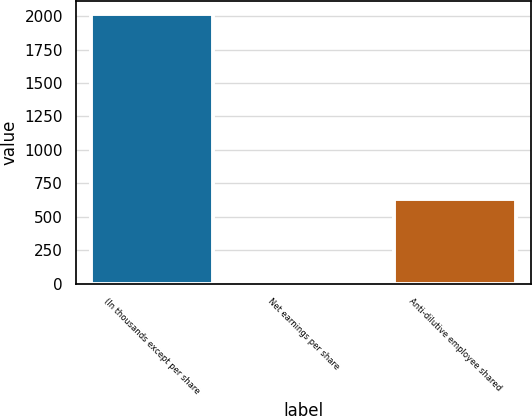Convert chart to OTSL. <chart><loc_0><loc_0><loc_500><loc_500><bar_chart><fcel>(In thousands except per share<fcel>Net earnings per share<fcel>Anti-dilutive employee shared<nl><fcel>2014<fcel>3.83<fcel>632<nl></chart> 